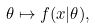Convert formula to latex. <formula><loc_0><loc_0><loc_500><loc_500>\theta \mapsto f ( x | \theta ) ,</formula> 